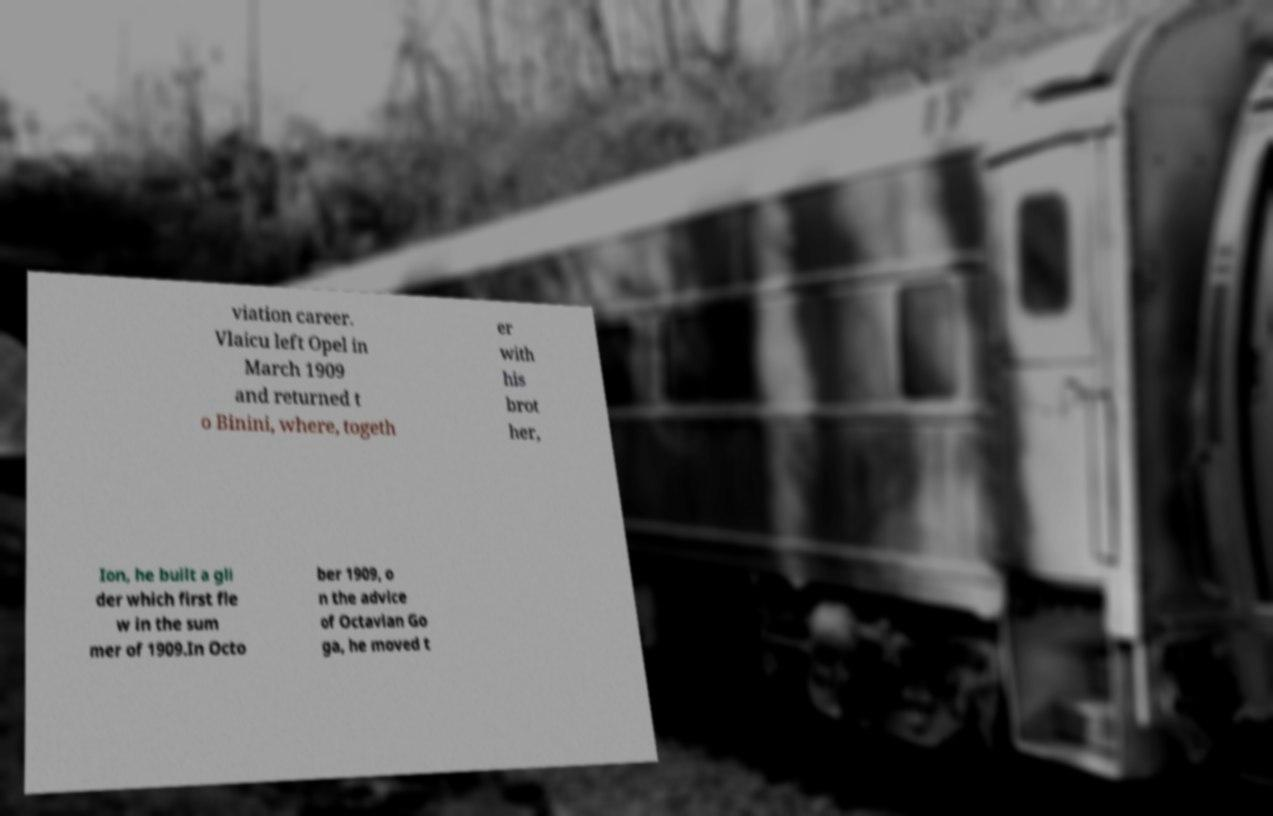What messages or text are displayed in this image? I need them in a readable, typed format. viation career. Vlaicu left Opel in March 1909 and returned t o Binini, where, togeth er with his brot her, Ion, he built a gli der which first fle w in the sum mer of 1909.In Octo ber 1909, o n the advice of Octavian Go ga, he moved t 